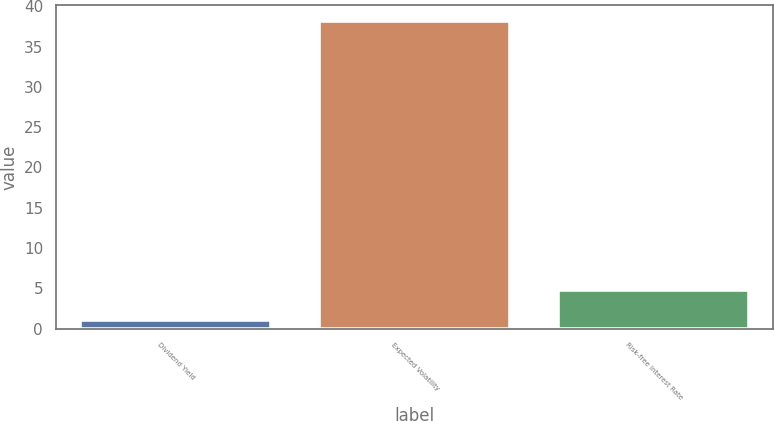Convert chart. <chart><loc_0><loc_0><loc_500><loc_500><bar_chart><fcel>Dividend Yield<fcel>Expected Volatility<fcel>Risk-free Interest Rate<nl><fcel>1.1<fcel>38.2<fcel>4.81<nl></chart> 